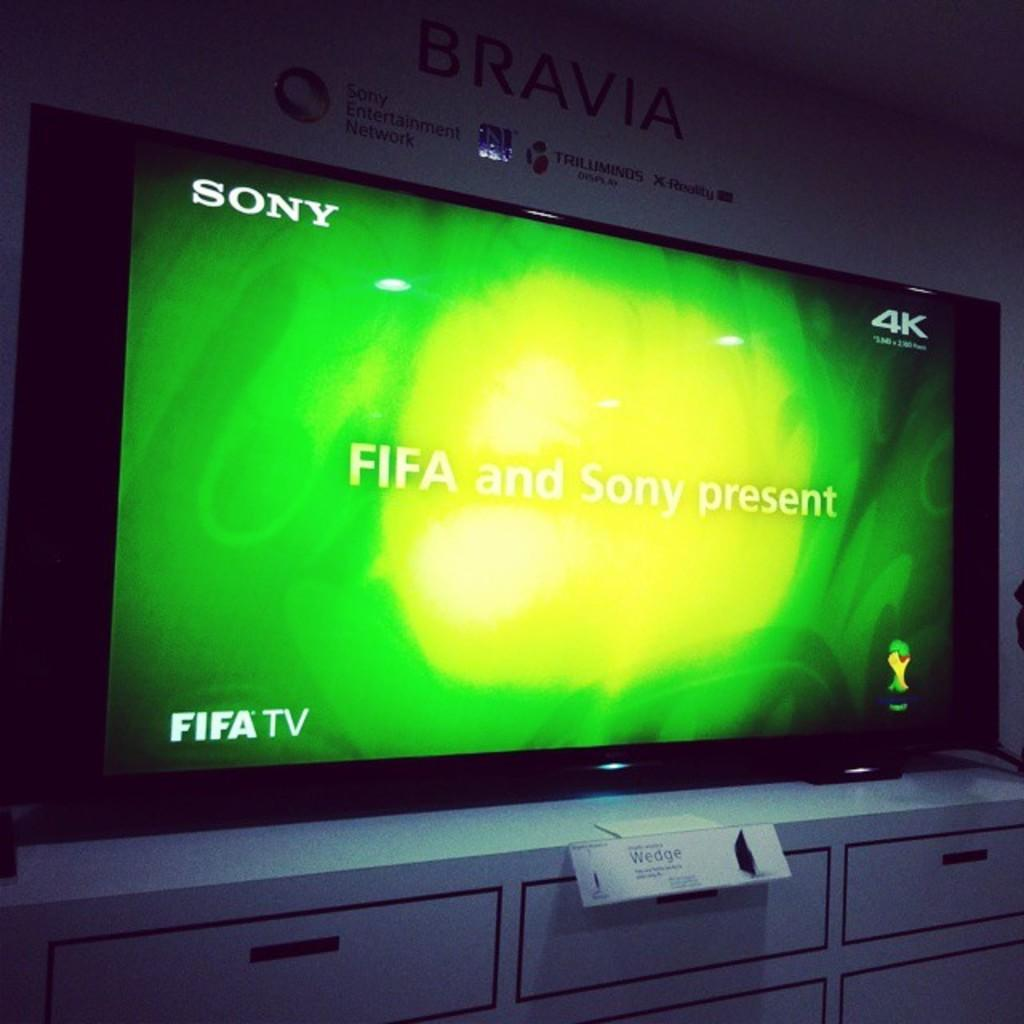<image>
Present a compact description of the photo's key features. A 4k Bravia TV on top of a white tv stand. 